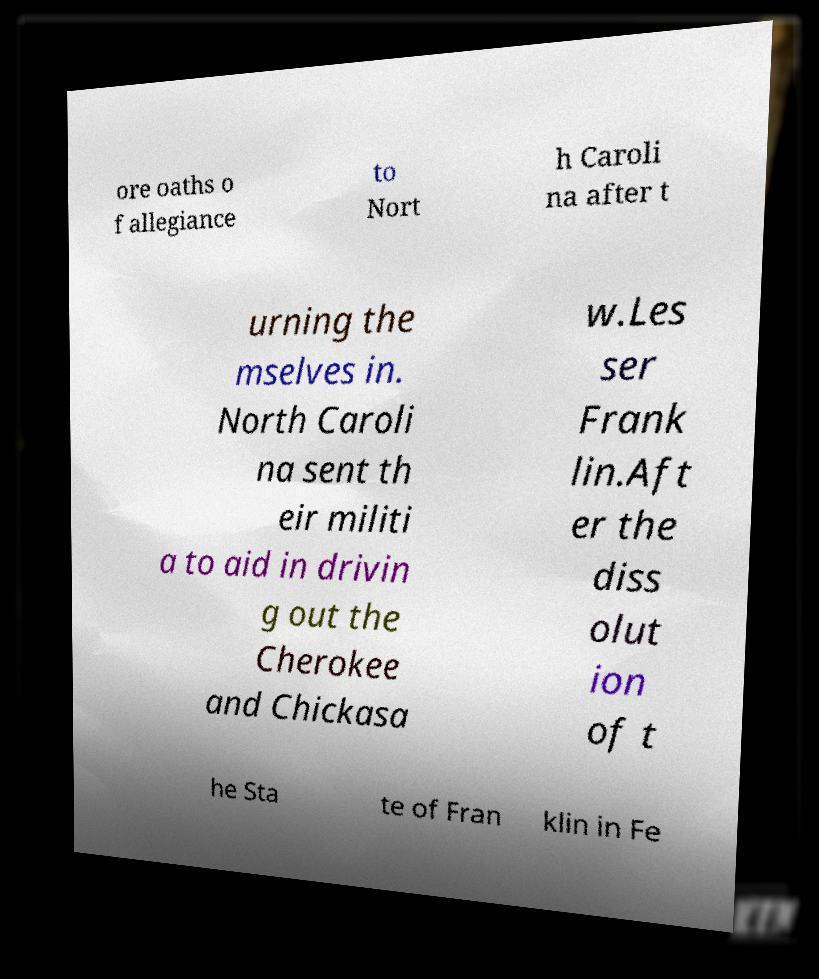There's text embedded in this image that I need extracted. Can you transcribe it verbatim? ore oaths o f allegiance to Nort h Caroli na after t urning the mselves in. North Caroli na sent th eir militi a to aid in drivin g out the Cherokee and Chickasa w.Les ser Frank lin.Aft er the diss olut ion of t he Sta te of Fran klin in Fe 